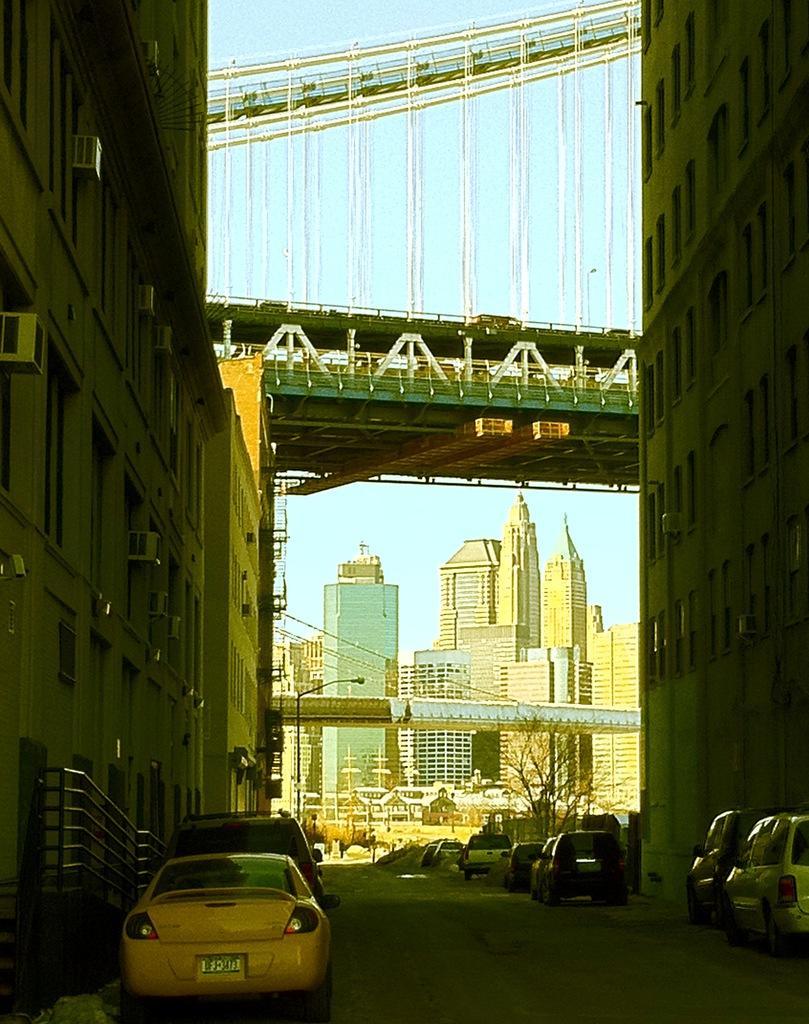Please provide a concise description of this image. This picture is clicked outside the city. On either side of the road, we see the buildings and the cars parked on the road. On the left side, we see the staircase and the stair railing. There are trees, buildings, street lights, cars and a bridge in the background. At the top, we see the bridge and the sky. 